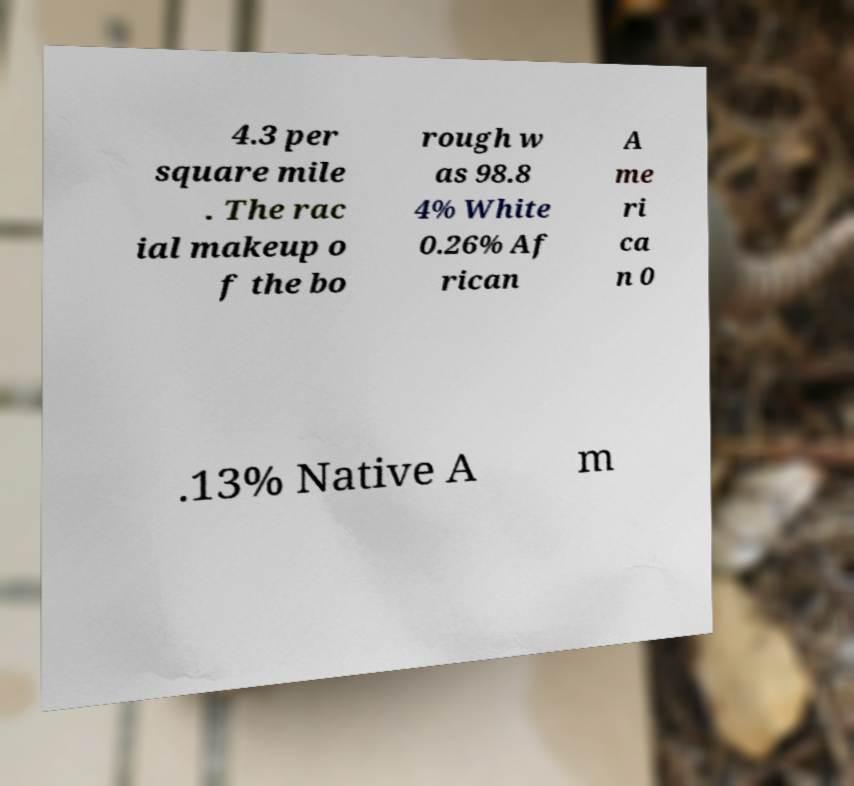Please read and relay the text visible in this image. What does it say? 4.3 per square mile . The rac ial makeup o f the bo rough w as 98.8 4% White 0.26% Af rican A me ri ca n 0 .13% Native A m 